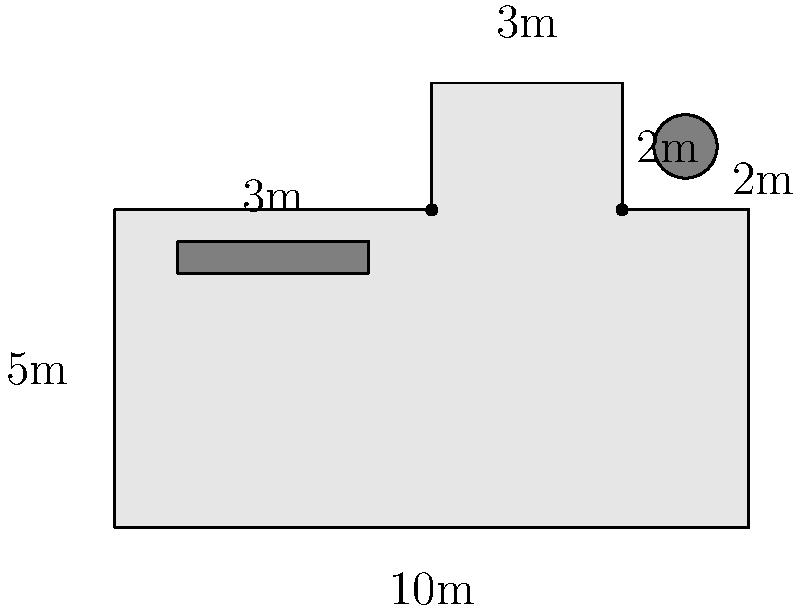In a historic courtroom, you're tasked with calculating the total floor area for renovations. The main courtroom has a rectangular shape of 10m by 5m, with a 2m by 3m extension on the upper right corner for the witness stand. There's also a 3m by 2m alcove on the upper left side. What is the total floor area of this courtroom in square meters? To calculate the total floor area, we'll break down the courtroom into regular shapes and add their areas:

1. Main rectangular area:
   $A_1 = 10\text{m} \times 5\text{m} = 50\text{m}^2$

2. Witness stand extension (upper right):
   $A_2 = 2\text{m} \times 3\text{m} = 6\text{m}^2$

3. Alcove (upper left):
   $A_3 = 3\text{m} \times 2\text{m} = 6\text{m}^2$

Total area:
$$A_{\text{total}} = A_1 + A_2 + A_3 = 50\text{m}^2 + 6\text{m}^2 + 6\text{m}^2 = 62\text{m}^2$$

Therefore, the total floor area of the courtroom is 62 square meters.
Answer: 62 m² 